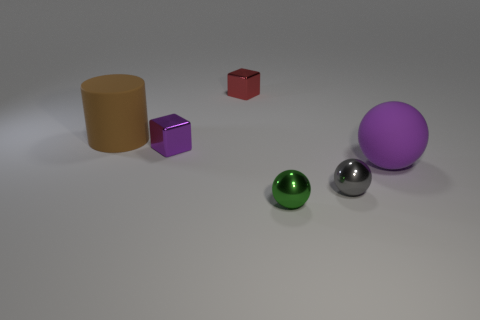Add 2 red shiny cylinders. How many objects exist? 8 Subtract all blocks. How many objects are left? 4 Add 5 large cylinders. How many large cylinders exist? 6 Subtract 1 brown cylinders. How many objects are left? 5 Subtract all small red metallic objects. Subtract all large purple rubber spheres. How many objects are left? 4 Add 5 brown cylinders. How many brown cylinders are left? 6 